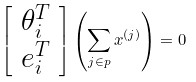Convert formula to latex. <formula><loc_0><loc_0><loc_500><loc_500>\left [ \begin{array} { c } \theta _ { i } ^ { T } \\ e _ { i } ^ { T } \end{array} \right ] \left ( \sum _ { j \in p } x ^ { ( j ) } \right ) = 0</formula> 